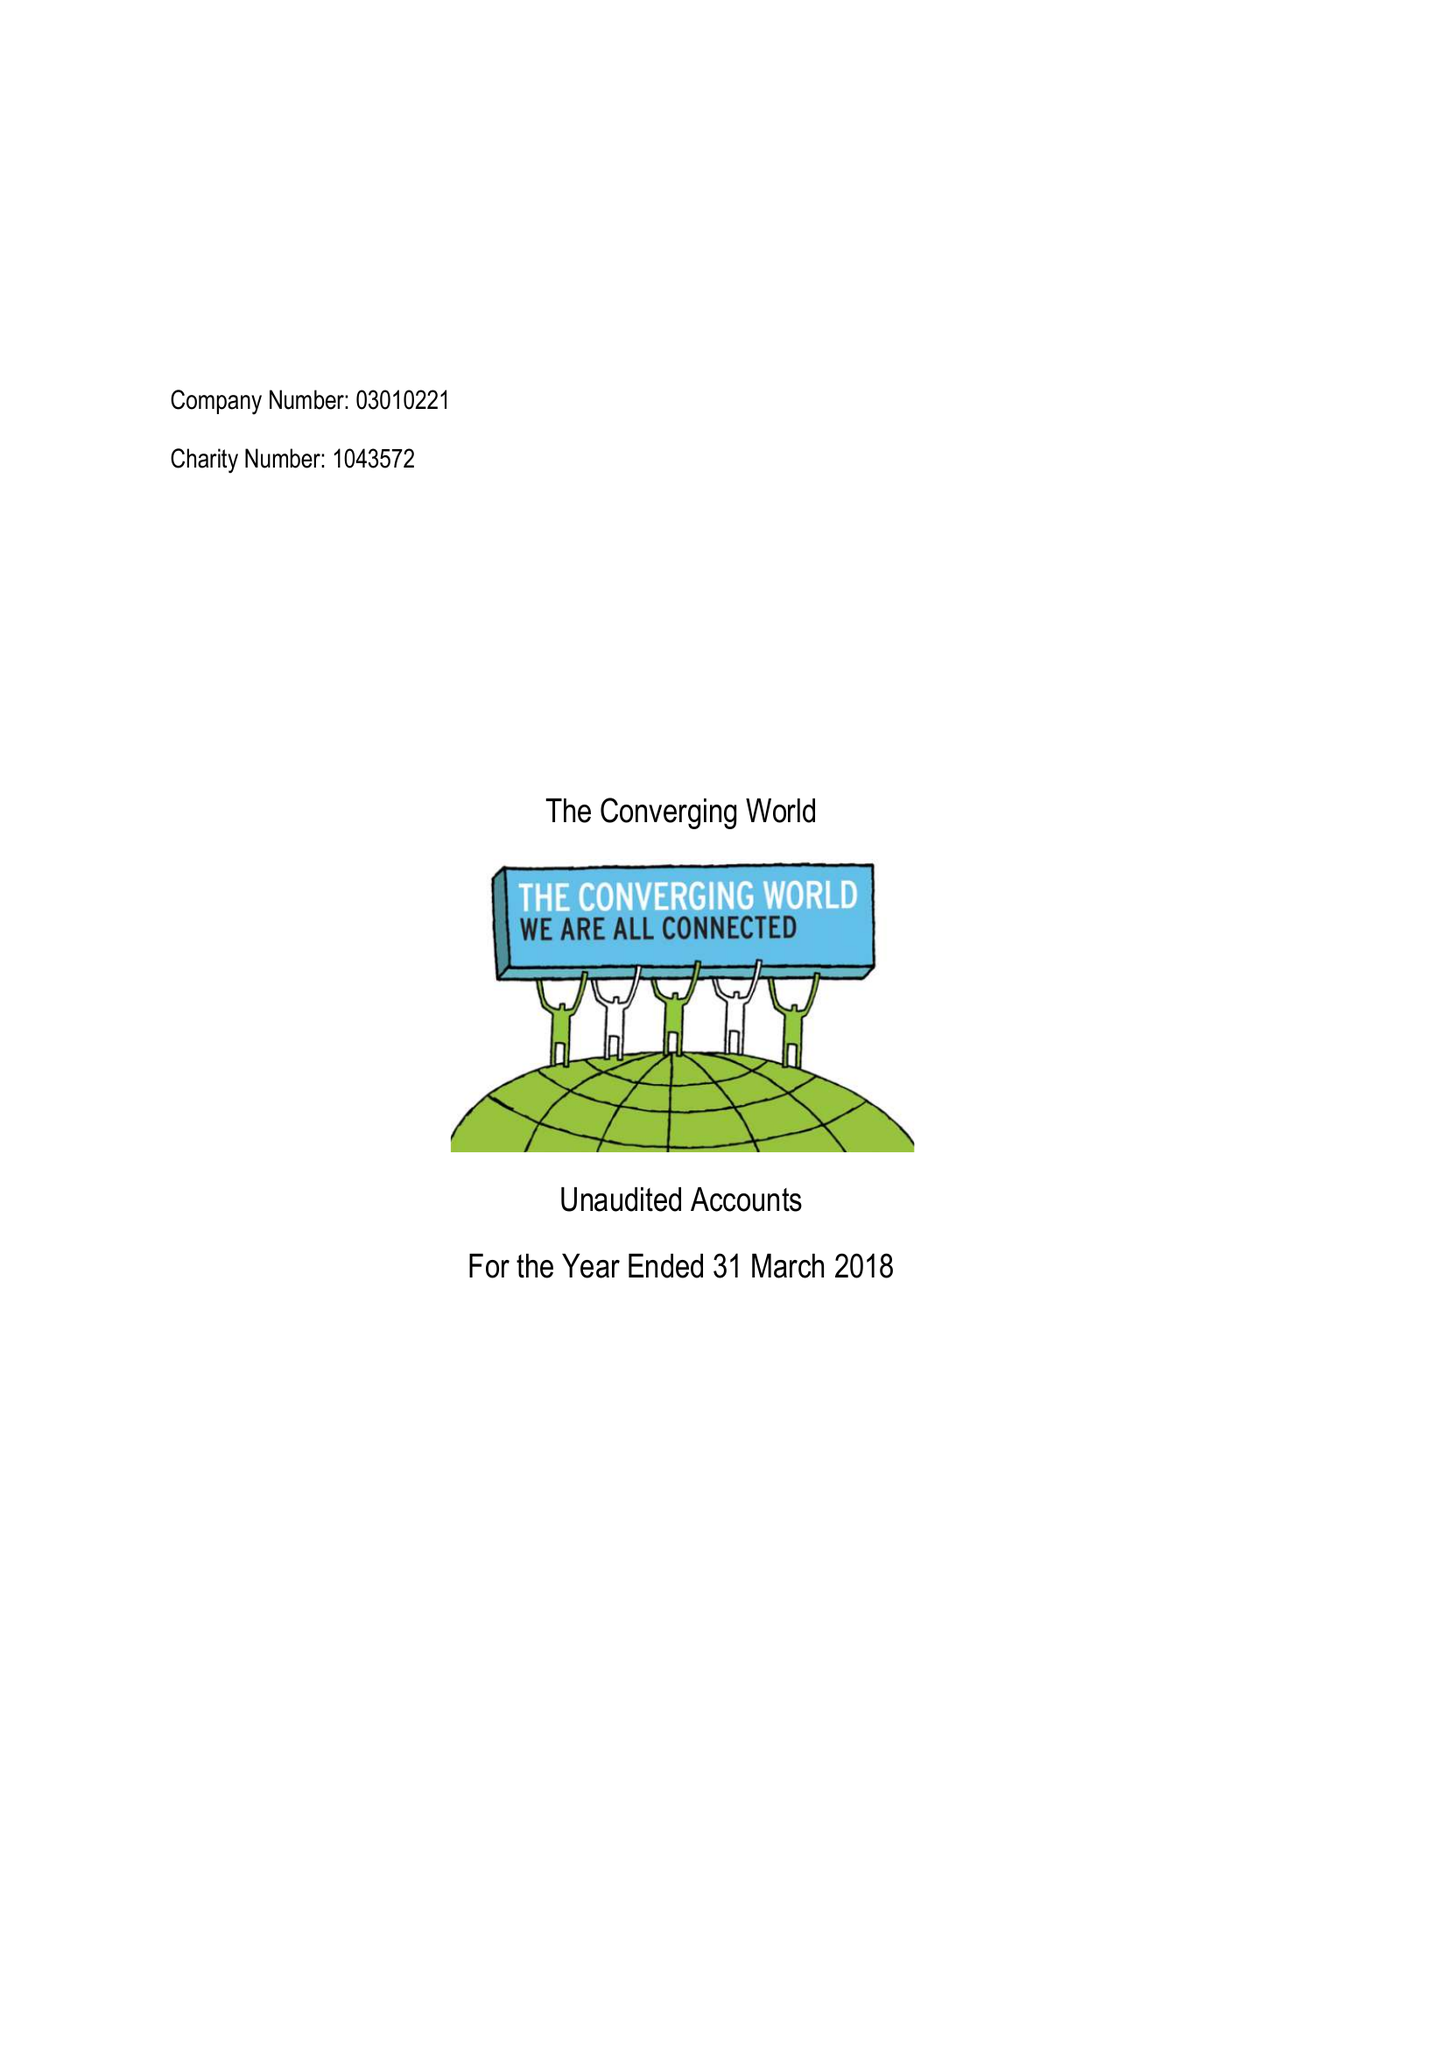What is the value for the spending_annually_in_british_pounds?
Answer the question using a single word or phrase. 66479.00 